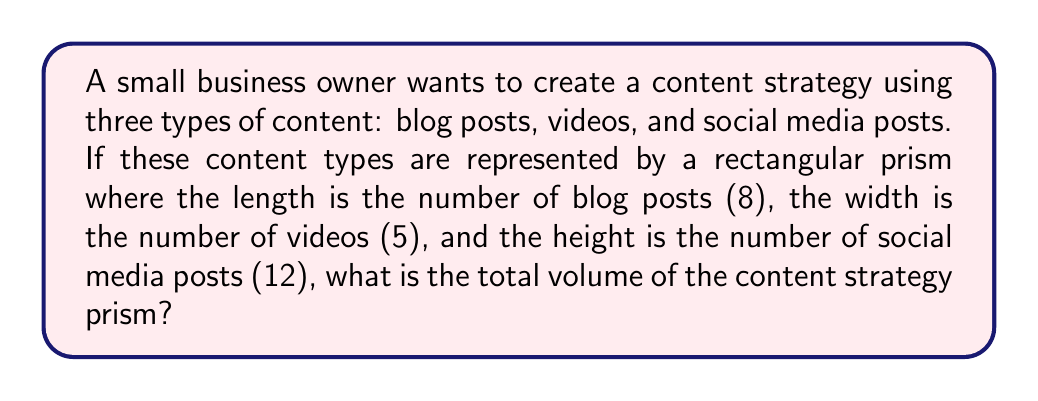Teach me how to tackle this problem. To solve this problem, we need to use the formula for the volume of a rectangular prism:

$$V = l \times w \times h$$

Where:
$V$ = volume
$l$ = length (number of blog posts)
$w$ = width (number of videos)
$h$ = height (number of social media posts)

Given:
$l = 8$ (blog posts)
$w = 5$ (videos)
$h = 12$ (social media posts)

Let's substitute these values into the formula:

$$V = 8 \times 5 \times 12$$

Now, let's calculate:

$$V = 40 \times 12 = 480$$

The volume of the content strategy prism is 480 content units.

This number represents the total possible combinations of content types in the strategy, which can help the business owner understand the potential scope and variety of their content plan.
Answer: 480 content units 